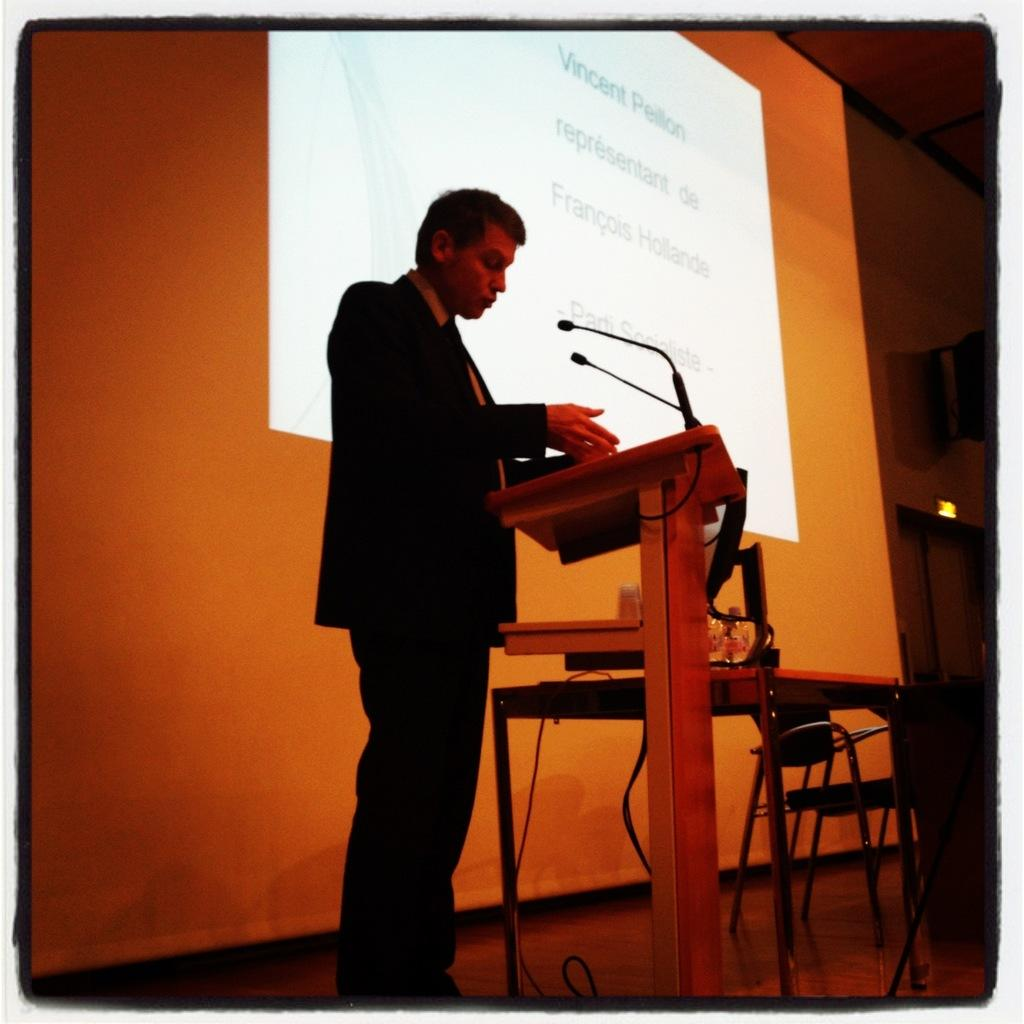What is the main subject of the image? There is a man standing in the image. What objects are related to the man's activity in the image? There are microphones (mics) and a podium in the image. What can be seen in the background of the image? There is a projector's screen, a table, and a chair in the background of the image. What type of cream is being served on the table in the image? There is no cream visible on the table in the image. How many thumbs can be seen on the man's hands in the image? The image does not show the man's hands, so it is impossible to determine the number of thumbs. 